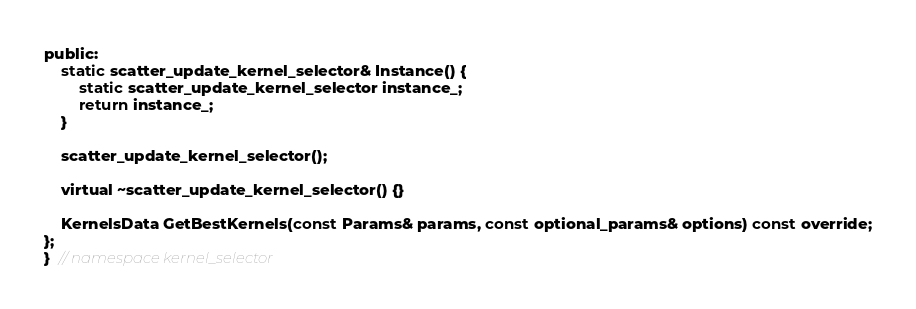<code> <loc_0><loc_0><loc_500><loc_500><_C_>public:
    static scatter_update_kernel_selector& Instance() {
        static scatter_update_kernel_selector instance_;
        return instance_;
    }

    scatter_update_kernel_selector();

    virtual ~scatter_update_kernel_selector() {}

    KernelsData GetBestKernels(const Params& params, const optional_params& options) const override;
};
}  // namespace kernel_selector
</code> 